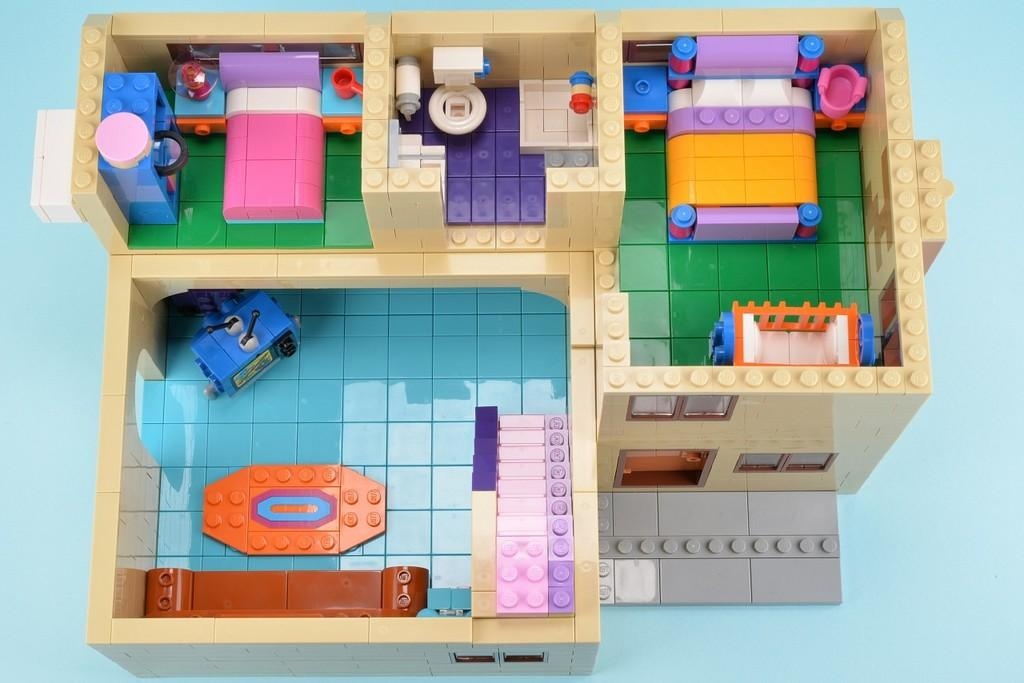What type of object is the main subject of the image? There is a toy house in the image. What type of bun can be seen on the roof of the toy house in the image? There is no bun present on the roof of the toy house in the image. Are there any fairies flying around the toy house in the image? There is no mention of fairies in the image, and therefore no such activity can be observed. 